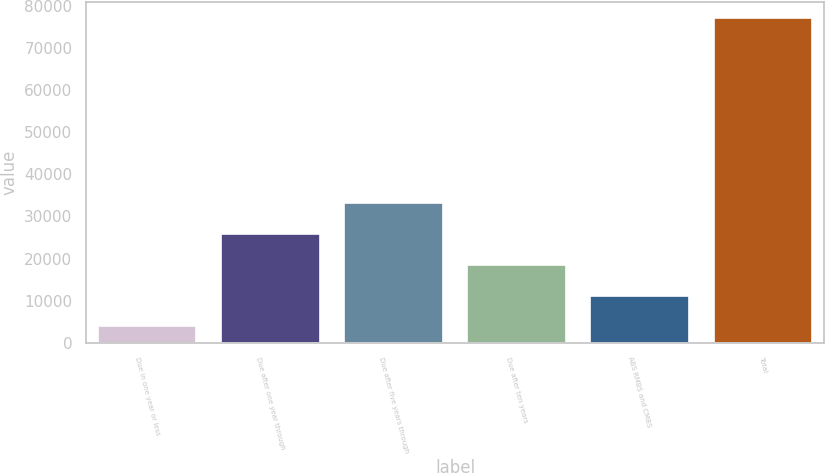Convert chart to OTSL. <chart><loc_0><loc_0><loc_500><loc_500><bar_chart><fcel>Due in one year or less<fcel>Due after one year through<fcel>Due after five years through<fcel>Due after ten years<fcel>ABS RMBS and CMBS<fcel>Total<nl><fcel>3872<fcel>25815.5<fcel>33130<fcel>18501<fcel>11186.5<fcel>77017<nl></chart> 